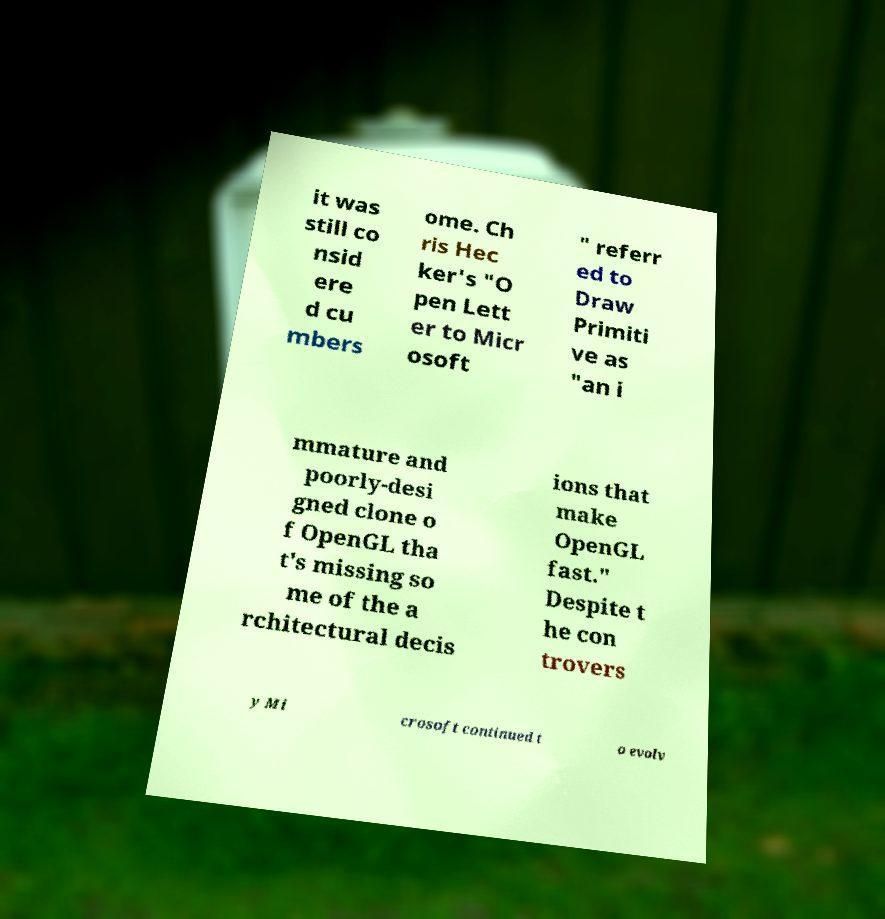Please read and relay the text visible in this image. What does it say? it was still co nsid ere d cu mbers ome. Ch ris Hec ker's "O pen Lett er to Micr osoft " referr ed to Draw Primiti ve as "an i mmature and poorly-desi gned clone o f OpenGL tha t's missing so me of the a rchitectural decis ions that make OpenGL fast." Despite t he con trovers y Mi crosoft continued t o evolv 